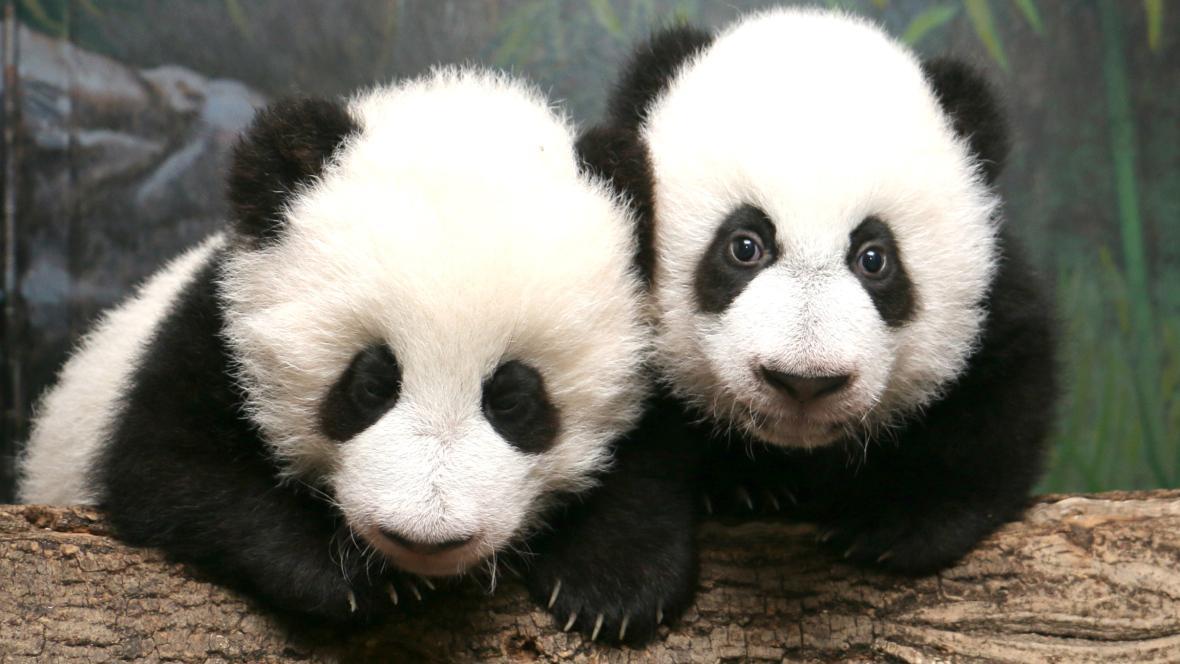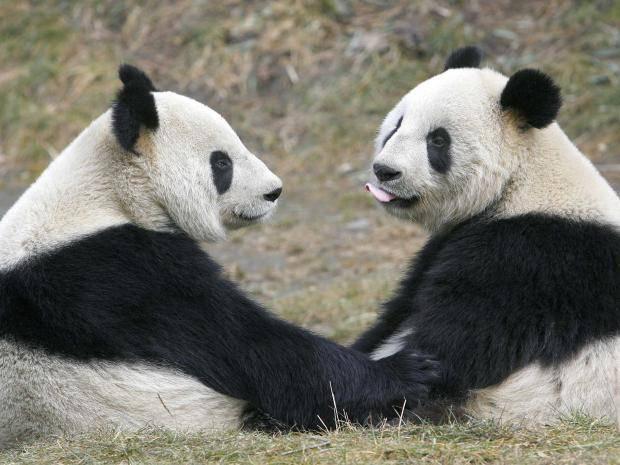The first image is the image on the left, the second image is the image on the right. Analyze the images presented: Is the assertion "The two pandas in the image on the left are eating bamboo shoots." valid? Answer yes or no. No. The first image is the image on the left, the second image is the image on the right. For the images shown, is this caption "Two pandas are face-to-face, one with its front paws touching the other, in the right image." true? Answer yes or no. Yes. 